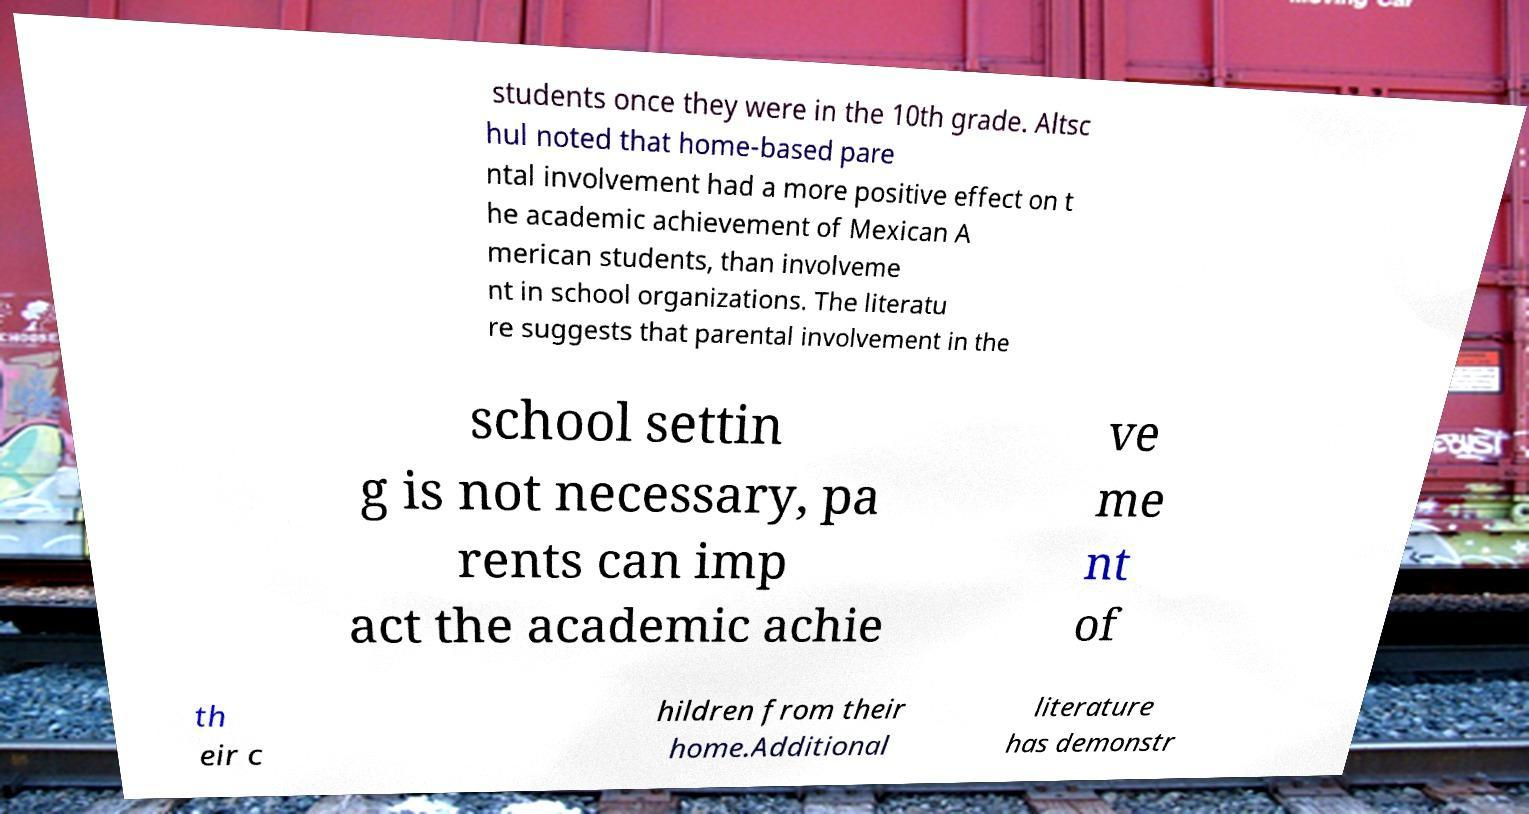What messages or text are displayed in this image? I need them in a readable, typed format. students once they were in the 10th grade. Altsc hul noted that home-based pare ntal involvement had a more positive effect on t he academic achievement of Mexican A merican students, than involveme nt in school organizations. The literatu re suggests that parental involvement in the school settin g is not necessary, pa rents can imp act the academic achie ve me nt of th eir c hildren from their home.Additional literature has demonstr 